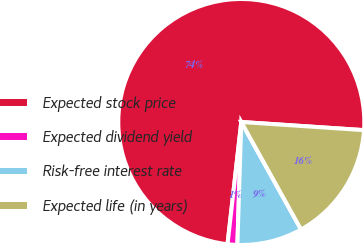<chart> <loc_0><loc_0><loc_500><loc_500><pie_chart><fcel>Expected stock price<fcel>Expected dividend yield<fcel>Risk-free interest rate<fcel>Expected life (in years)<nl><fcel>74.27%<fcel>1.28%<fcel>8.58%<fcel>15.87%<nl></chart> 